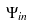Convert formula to latex. <formula><loc_0><loc_0><loc_500><loc_500>\Psi _ { i n }</formula> 